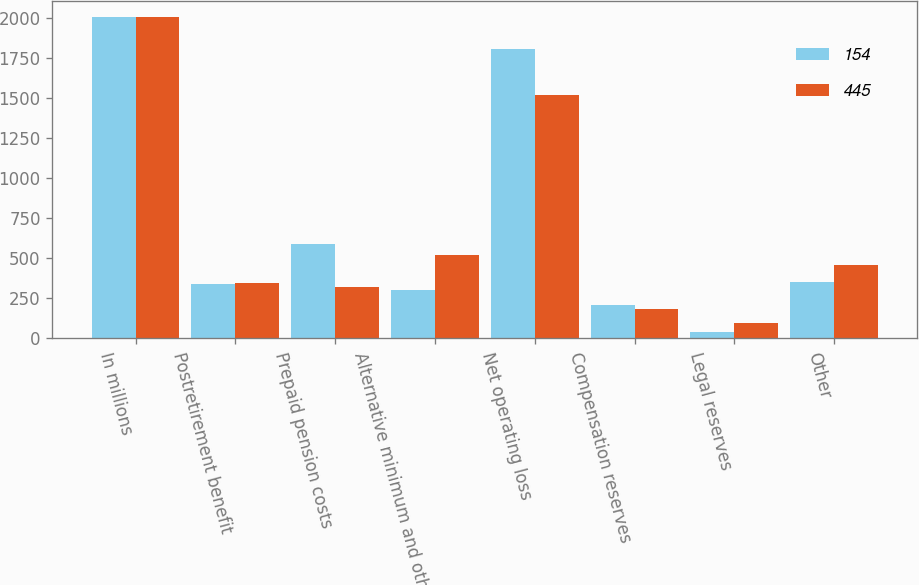<chart> <loc_0><loc_0><loc_500><loc_500><stacked_bar_chart><ecel><fcel>In millions<fcel>Postretirement benefit<fcel>Prepaid pension costs<fcel>Alternative minimum and other<fcel>Net operating loss<fcel>Compensation reserves<fcel>Legal reserves<fcel>Other<nl><fcel>154<fcel>2005<fcel>339<fcel>589<fcel>300<fcel>1807<fcel>211<fcel>40<fcel>349<nl><fcel>445<fcel>2004<fcel>348<fcel>320<fcel>519<fcel>1518<fcel>186<fcel>98<fcel>457<nl></chart> 